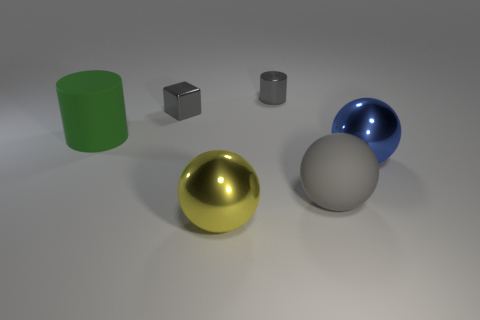What shape is the matte object that is the same color as the block?
Your response must be concise. Sphere. There is a matte object that is on the right side of the green matte object; is it the same shape as the large yellow metallic object on the right side of the big green thing?
Offer a terse response. Yes. What is the material of the large thing behind the big object on the right side of the large matte thing that is to the right of the green matte cylinder?
Offer a very short reply. Rubber. What shape is the yellow object that is the same size as the blue shiny ball?
Ensure brevity in your answer.  Sphere. Are there any shiny objects that have the same color as the big cylinder?
Provide a short and direct response. No. The metallic block is what size?
Your answer should be compact. Small. Are the small gray cylinder and the green cylinder made of the same material?
Your answer should be very brief. No. There is a small gray shiny thing on the left side of the sphere in front of the big gray thing; what number of cubes are to the left of it?
Your answer should be compact. 0. What shape is the rubber object that is right of the big green rubber thing?
Your answer should be very brief. Sphere. What number of other things are there of the same material as the large yellow sphere
Offer a very short reply. 3. 